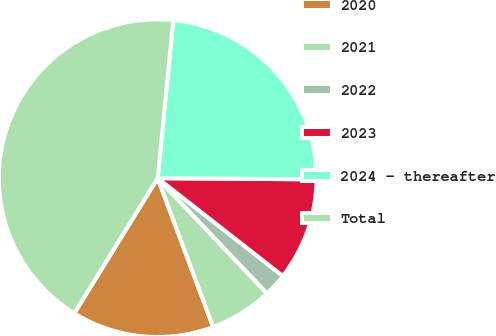Convert chart to OTSL. <chart><loc_0><loc_0><loc_500><loc_500><pie_chart><fcel>2020<fcel>2021<fcel>2022<fcel>2023<fcel>2024 - thereafter<fcel>Total<nl><fcel>14.48%<fcel>6.4%<fcel>2.36%<fcel>10.44%<fcel>23.55%<fcel>42.76%<nl></chart> 